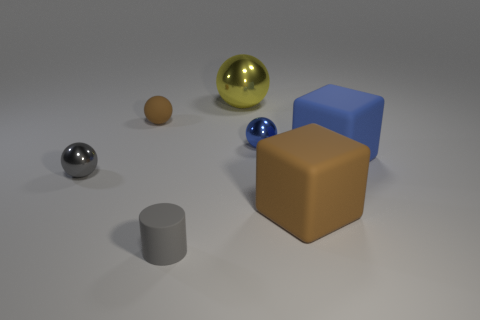What can you infer about the lighting conditions in this scene? The lighting in this scene is soft and diffused, casting gentle shadows beneath each object, indicating what might be an overcast day or soft-box light in a studio environment. The lack of harsh shadows or high contrast suggests that the light source is either large or situated far from the objects. Reflections on the spherical objects subtly reveal a bright light source coming from the upper left of the frame, illuminating the scene evenly. 